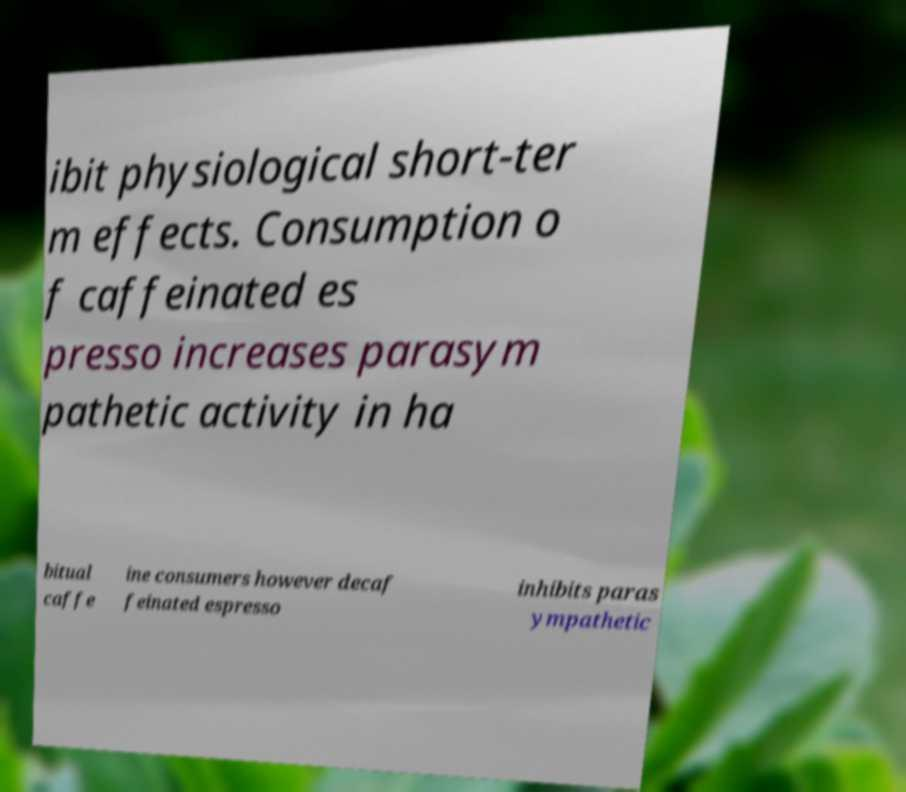Please identify and transcribe the text found in this image. ibit physiological short-ter m effects. Consumption o f caffeinated es presso increases parasym pathetic activity in ha bitual caffe ine consumers however decaf feinated espresso inhibits paras ympathetic 